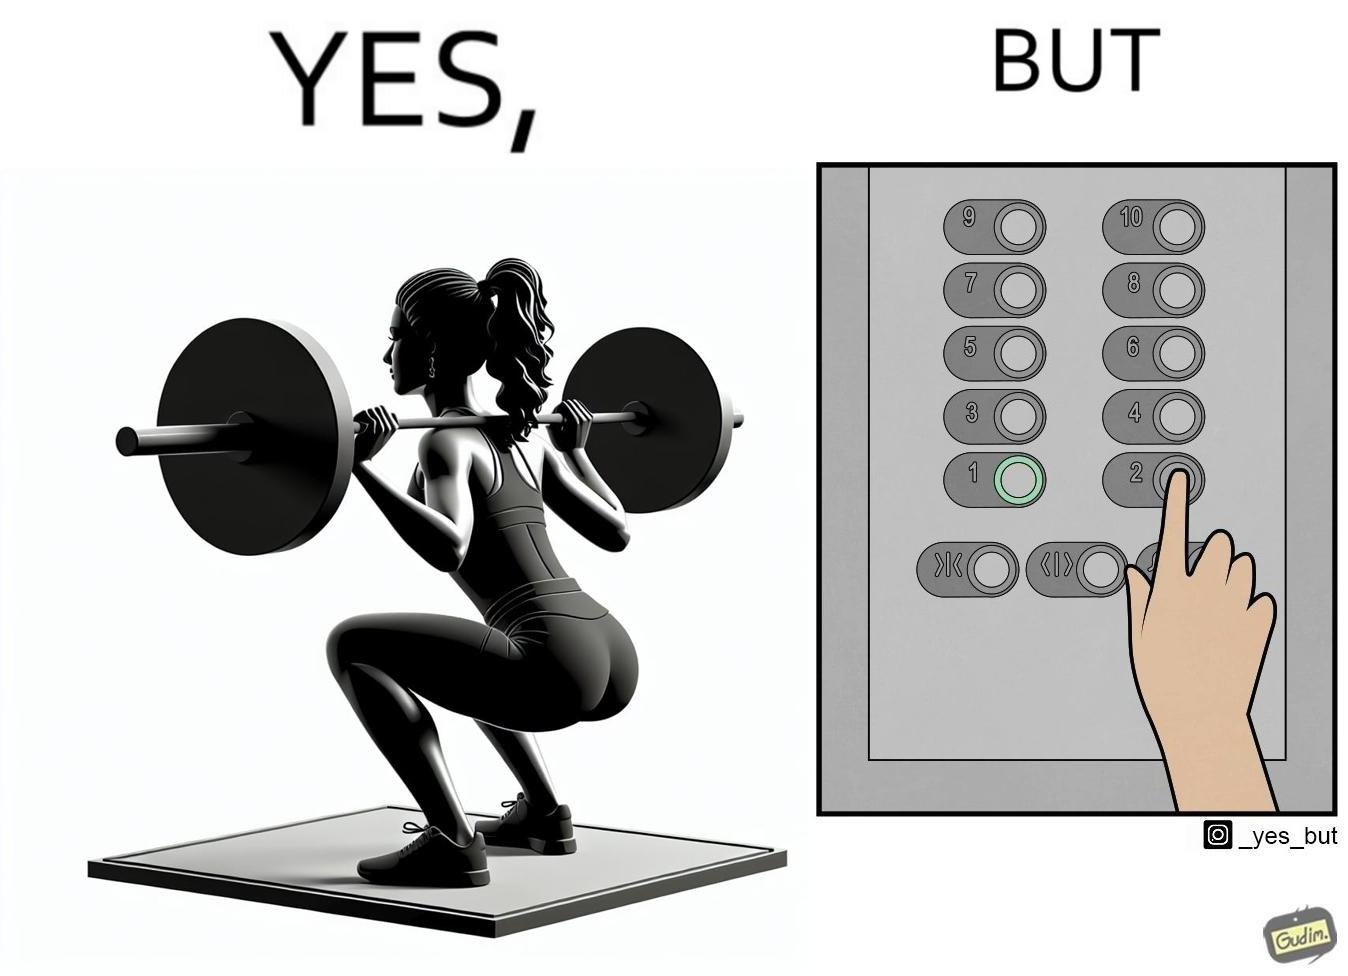Compare the left and right sides of this image. In the left part of the image: The image shows a women exercising with a bar bell in a gym. She is wearing a sport outfit. She is crouching down on one leg doing a single leg squat with a bar bell. In the right part of the image: The image shows the control panel inside of an elevator. The indicator for the first floor is green which means the button for the first floor was pressed. A hand is about to press the button for the second floor. 